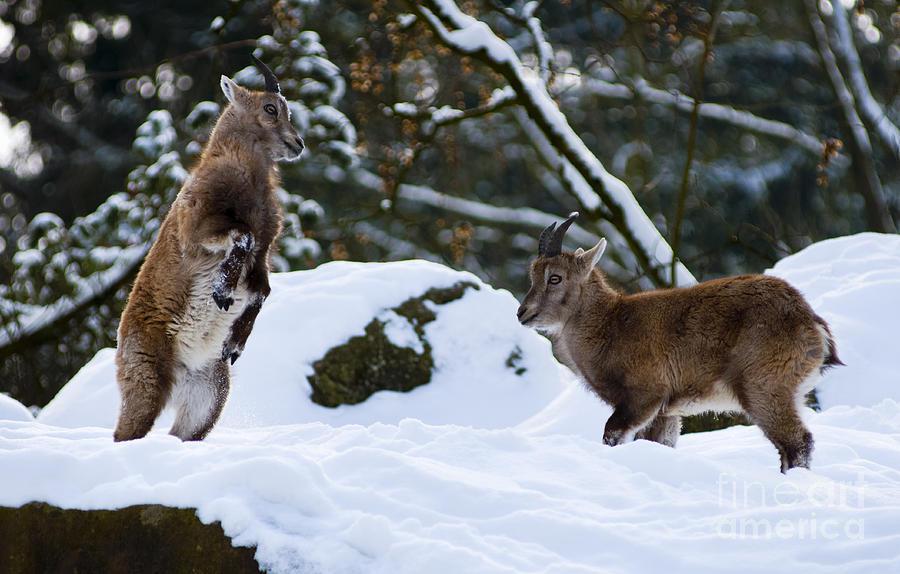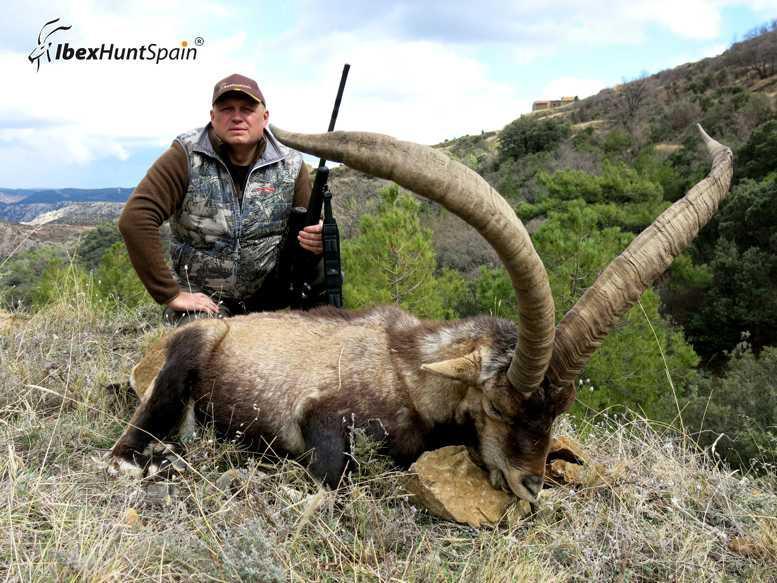The first image is the image on the left, the second image is the image on the right. For the images displayed, is the sentence "The left picture does not have a human in it." factually correct? Answer yes or no. Yes. The first image is the image on the left, the second image is the image on the right. For the images shown, is this caption "The left and right image contains a total of  two goats with at least two hunters." true? Answer yes or no. No. 